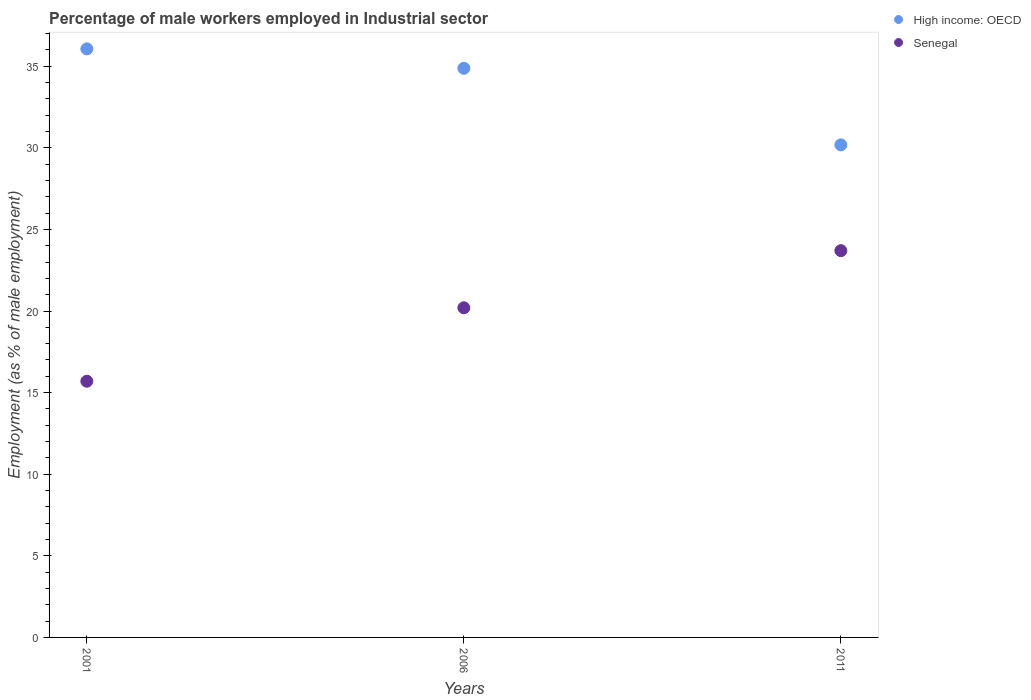What is the percentage of male workers employed in Industrial sector in Senegal in 2001?
Give a very brief answer. 15.7. Across all years, what is the maximum percentage of male workers employed in Industrial sector in Senegal?
Ensure brevity in your answer.  23.7. Across all years, what is the minimum percentage of male workers employed in Industrial sector in High income: OECD?
Your answer should be compact. 30.18. In which year was the percentage of male workers employed in Industrial sector in Senegal minimum?
Offer a terse response. 2001. What is the total percentage of male workers employed in Industrial sector in High income: OECD in the graph?
Your response must be concise. 101.12. What is the difference between the percentage of male workers employed in Industrial sector in High income: OECD in 2001 and that in 2006?
Ensure brevity in your answer.  1.19. What is the difference between the percentage of male workers employed in Industrial sector in Senegal in 2006 and the percentage of male workers employed in Industrial sector in High income: OECD in 2011?
Keep it short and to the point. -9.98. What is the average percentage of male workers employed in Industrial sector in Senegal per year?
Provide a short and direct response. 19.87. In the year 2001, what is the difference between the percentage of male workers employed in Industrial sector in High income: OECD and percentage of male workers employed in Industrial sector in Senegal?
Provide a succinct answer. 20.37. In how many years, is the percentage of male workers employed in Industrial sector in Senegal greater than 14 %?
Your answer should be very brief. 3. What is the ratio of the percentage of male workers employed in Industrial sector in High income: OECD in 2001 to that in 2006?
Provide a short and direct response. 1.03. What is the difference between the highest and the second highest percentage of male workers employed in Industrial sector in High income: OECD?
Provide a short and direct response. 1.19. What is the difference between the highest and the lowest percentage of male workers employed in Industrial sector in Senegal?
Provide a short and direct response. 8. In how many years, is the percentage of male workers employed in Industrial sector in High income: OECD greater than the average percentage of male workers employed in Industrial sector in High income: OECD taken over all years?
Your answer should be compact. 2. Is the sum of the percentage of male workers employed in Industrial sector in High income: OECD in 2006 and 2011 greater than the maximum percentage of male workers employed in Industrial sector in Senegal across all years?
Your response must be concise. Yes. Does the percentage of male workers employed in Industrial sector in High income: OECD monotonically increase over the years?
Ensure brevity in your answer.  No. Is the percentage of male workers employed in Industrial sector in Senegal strictly less than the percentage of male workers employed in Industrial sector in High income: OECD over the years?
Your answer should be very brief. Yes. How many dotlines are there?
Offer a terse response. 2. How many years are there in the graph?
Provide a succinct answer. 3. What is the difference between two consecutive major ticks on the Y-axis?
Offer a terse response. 5. Does the graph contain any zero values?
Offer a terse response. No. How many legend labels are there?
Provide a short and direct response. 2. How are the legend labels stacked?
Your response must be concise. Vertical. What is the title of the graph?
Provide a short and direct response. Percentage of male workers employed in Industrial sector. Does "Namibia" appear as one of the legend labels in the graph?
Offer a very short reply. No. What is the label or title of the Y-axis?
Give a very brief answer. Employment (as % of male employment). What is the Employment (as % of male employment) in High income: OECD in 2001?
Provide a short and direct response. 36.07. What is the Employment (as % of male employment) in Senegal in 2001?
Keep it short and to the point. 15.7. What is the Employment (as % of male employment) of High income: OECD in 2006?
Provide a succinct answer. 34.87. What is the Employment (as % of male employment) of Senegal in 2006?
Offer a very short reply. 20.2. What is the Employment (as % of male employment) in High income: OECD in 2011?
Offer a very short reply. 30.18. What is the Employment (as % of male employment) of Senegal in 2011?
Keep it short and to the point. 23.7. Across all years, what is the maximum Employment (as % of male employment) in High income: OECD?
Provide a short and direct response. 36.07. Across all years, what is the maximum Employment (as % of male employment) in Senegal?
Give a very brief answer. 23.7. Across all years, what is the minimum Employment (as % of male employment) in High income: OECD?
Ensure brevity in your answer.  30.18. Across all years, what is the minimum Employment (as % of male employment) of Senegal?
Offer a terse response. 15.7. What is the total Employment (as % of male employment) of High income: OECD in the graph?
Your response must be concise. 101.12. What is the total Employment (as % of male employment) of Senegal in the graph?
Provide a short and direct response. 59.6. What is the difference between the Employment (as % of male employment) of High income: OECD in 2001 and that in 2006?
Ensure brevity in your answer.  1.19. What is the difference between the Employment (as % of male employment) of Senegal in 2001 and that in 2006?
Make the answer very short. -4.5. What is the difference between the Employment (as % of male employment) in High income: OECD in 2001 and that in 2011?
Give a very brief answer. 5.88. What is the difference between the Employment (as % of male employment) of Senegal in 2001 and that in 2011?
Offer a terse response. -8. What is the difference between the Employment (as % of male employment) in High income: OECD in 2006 and that in 2011?
Ensure brevity in your answer.  4.69. What is the difference between the Employment (as % of male employment) of Senegal in 2006 and that in 2011?
Your answer should be compact. -3.5. What is the difference between the Employment (as % of male employment) in High income: OECD in 2001 and the Employment (as % of male employment) in Senegal in 2006?
Your answer should be very brief. 15.87. What is the difference between the Employment (as % of male employment) of High income: OECD in 2001 and the Employment (as % of male employment) of Senegal in 2011?
Keep it short and to the point. 12.37. What is the difference between the Employment (as % of male employment) of High income: OECD in 2006 and the Employment (as % of male employment) of Senegal in 2011?
Give a very brief answer. 11.17. What is the average Employment (as % of male employment) in High income: OECD per year?
Provide a succinct answer. 33.71. What is the average Employment (as % of male employment) of Senegal per year?
Keep it short and to the point. 19.87. In the year 2001, what is the difference between the Employment (as % of male employment) in High income: OECD and Employment (as % of male employment) in Senegal?
Provide a short and direct response. 20.37. In the year 2006, what is the difference between the Employment (as % of male employment) of High income: OECD and Employment (as % of male employment) of Senegal?
Provide a short and direct response. 14.67. In the year 2011, what is the difference between the Employment (as % of male employment) of High income: OECD and Employment (as % of male employment) of Senegal?
Your answer should be very brief. 6.48. What is the ratio of the Employment (as % of male employment) of High income: OECD in 2001 to that in 2006?
Keep it short and to the point. 1.03. What is the ratio of the Employment (as % of male employment) of Senegal in 2001 to that in 2006?
Keep it short and to the point. 0.78. What is the ratio of the Employment (as % of male employment) in High income: OECD in 2001 to that in 2011?
Ensure brevity in your answer.  1.19. What is the ratio of the Employment (as % of male employment) in Senegal in 2001 to that in 2011?
Offer a very short reply. 0.66. What is the ratio of the Employment (as % of male employment) in High income: OECD in 2006 to that in 2011?
Your answer should be compact. 1.16. What is the ratio of the Employment (as % of male employment) in Senegal in 2006 to that in 2011?
Make the answer very short. 0.85. What is the difference between the highest and the second highest Employment (as % of male employment) in High income: OECD?
Ensure brevity in your answer.  1.19. What is the difference between the highest and the lowest Employment (as % of male employment) of High income: OECD?
Your response must be concise. 5.88. What is the difference between the highest and the lowest Employment (as % of male employment) in Senegal?
Ensure brevity in your answer.  8. 